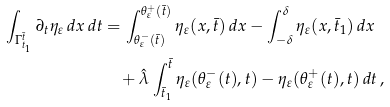Convert formula to latex. <formula><loc_0><loc_0><loc_500><loc_500>\int _ { \Gamma _ { t _ { 1 } } ^ { \bar { t } } } \partial _ { t } \eta _ { \varepsilon } \, d x \, d t & = \int _ { \theta ^ { - } _ { \varepsilon } ( \bar { t } ) } ^ { \theta ^ { + } _ { \varepsilon } ( \bar { t } ) } \eta _ { \varepsilon } ( x , \bar { t } ) \, d x - \int _ { - \delta } ^ { \delta } \eta _ { \varepsilon } ( x , \bar { t } _ { 1 } ) \, d x \\ & \quad + \hat { \lambda } \int _ { \bar { t } _ { 1 } } ^ { \bar { t } } \eta _ { \varepsilon } ( \theta ^ { - } _ { \varepsilon } ( t ) , t ) - \eta _ { \varepsilon } ( \theta ^ { + } _ { \varepsilon } ( t ) , t ) \, d t \, ,</formula> 